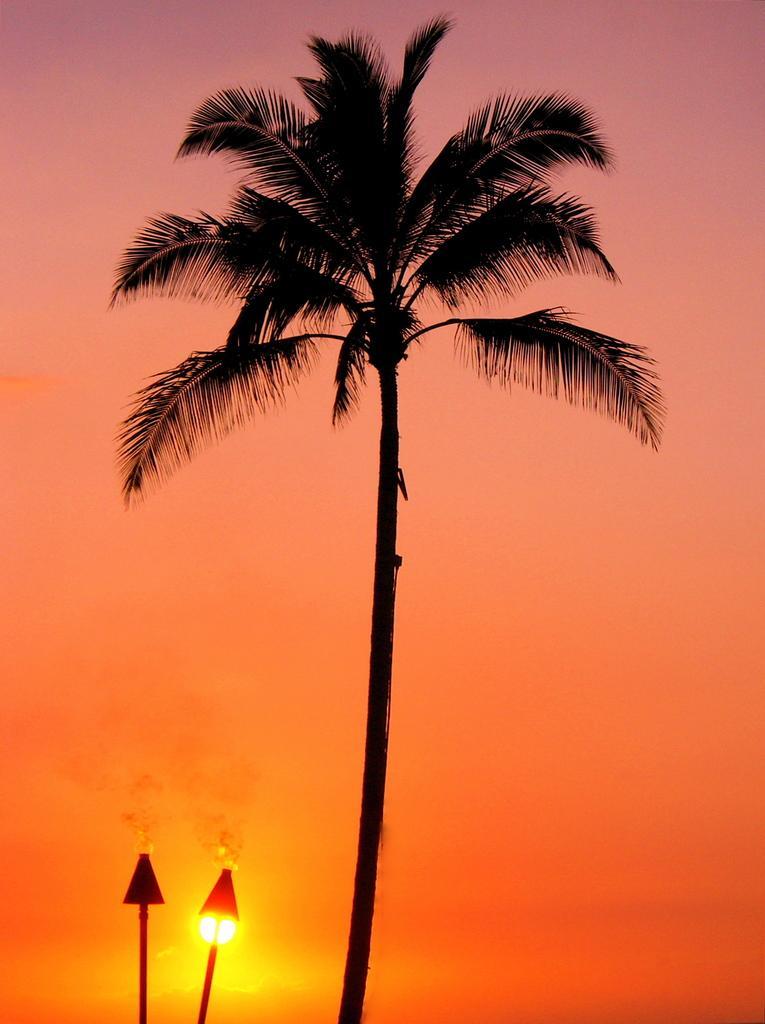How would you summarize this image in a sentence or two? In the background we can see the sky and the sun is visible. In this picture we can see the objects. This picture is mainly highlighted with a tree. 